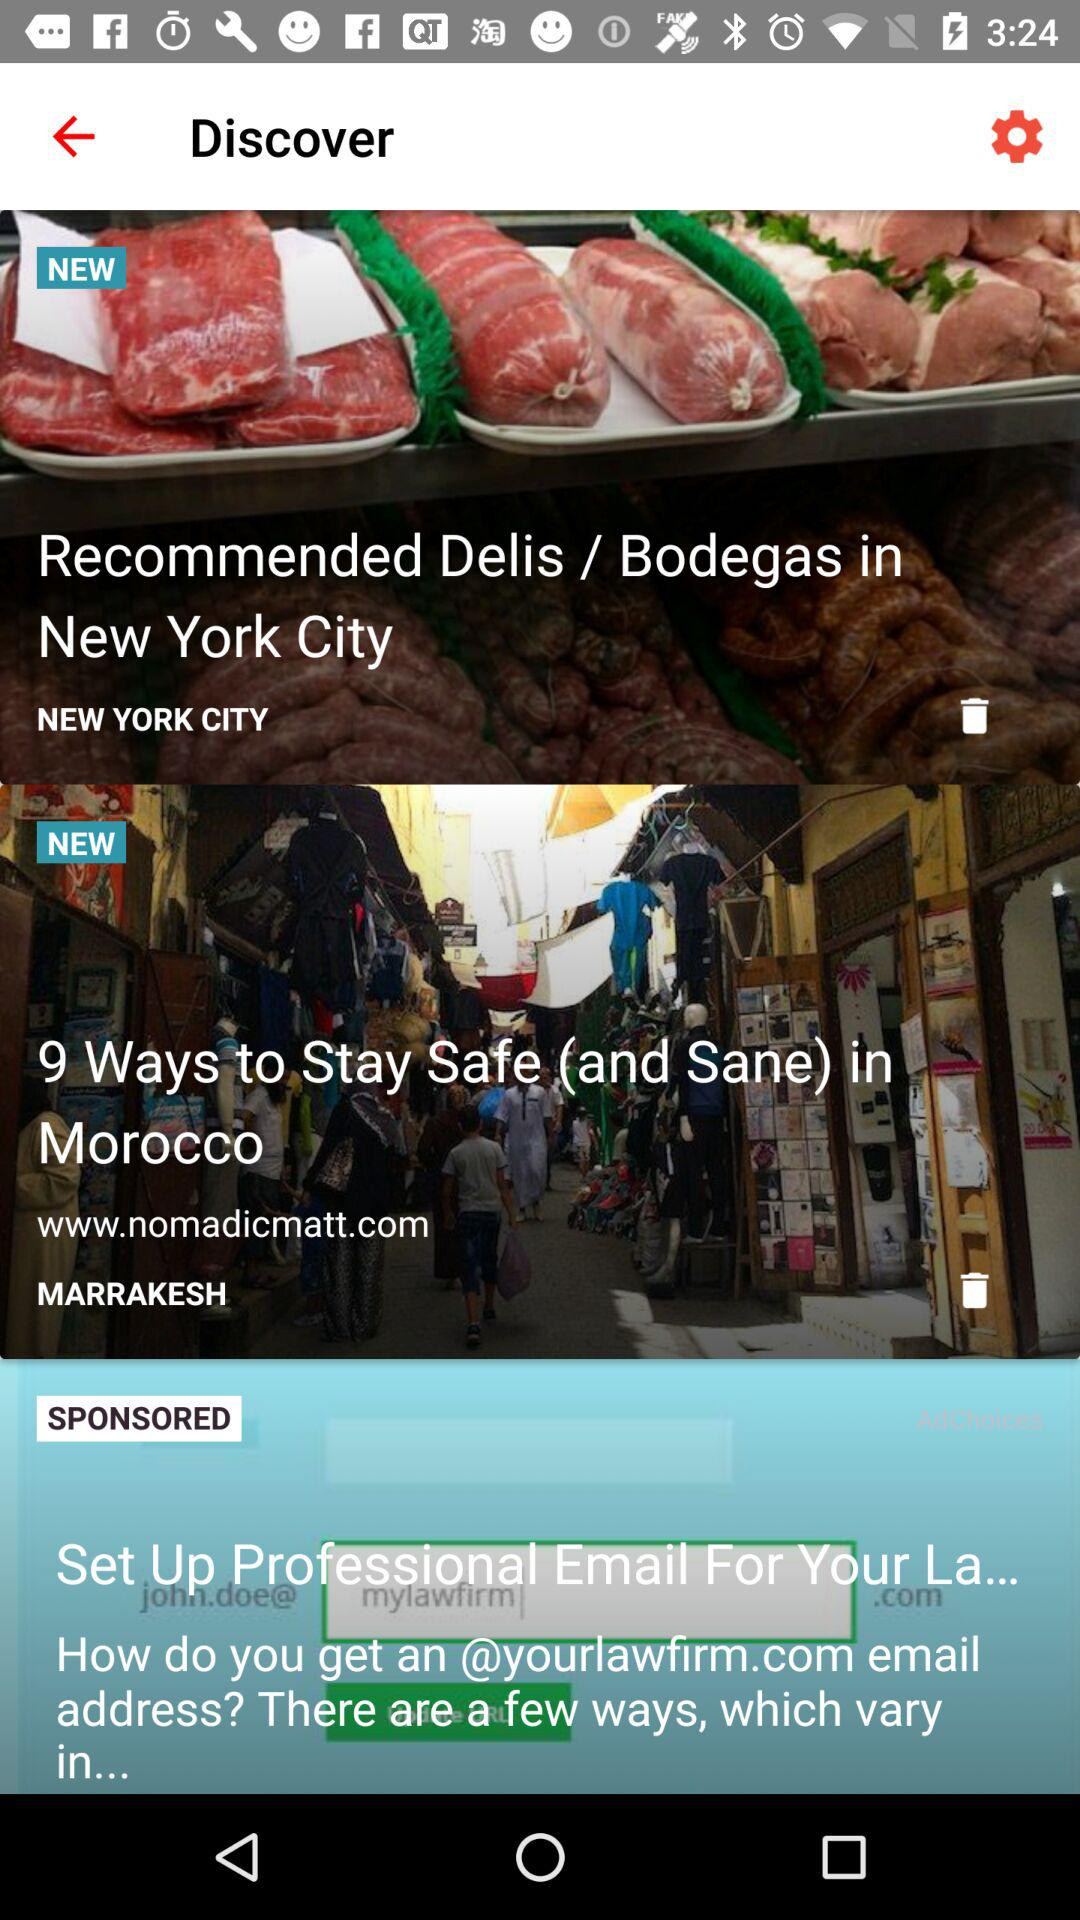How many items are sponsored?
Answer the question using a single word or phrase. 1 